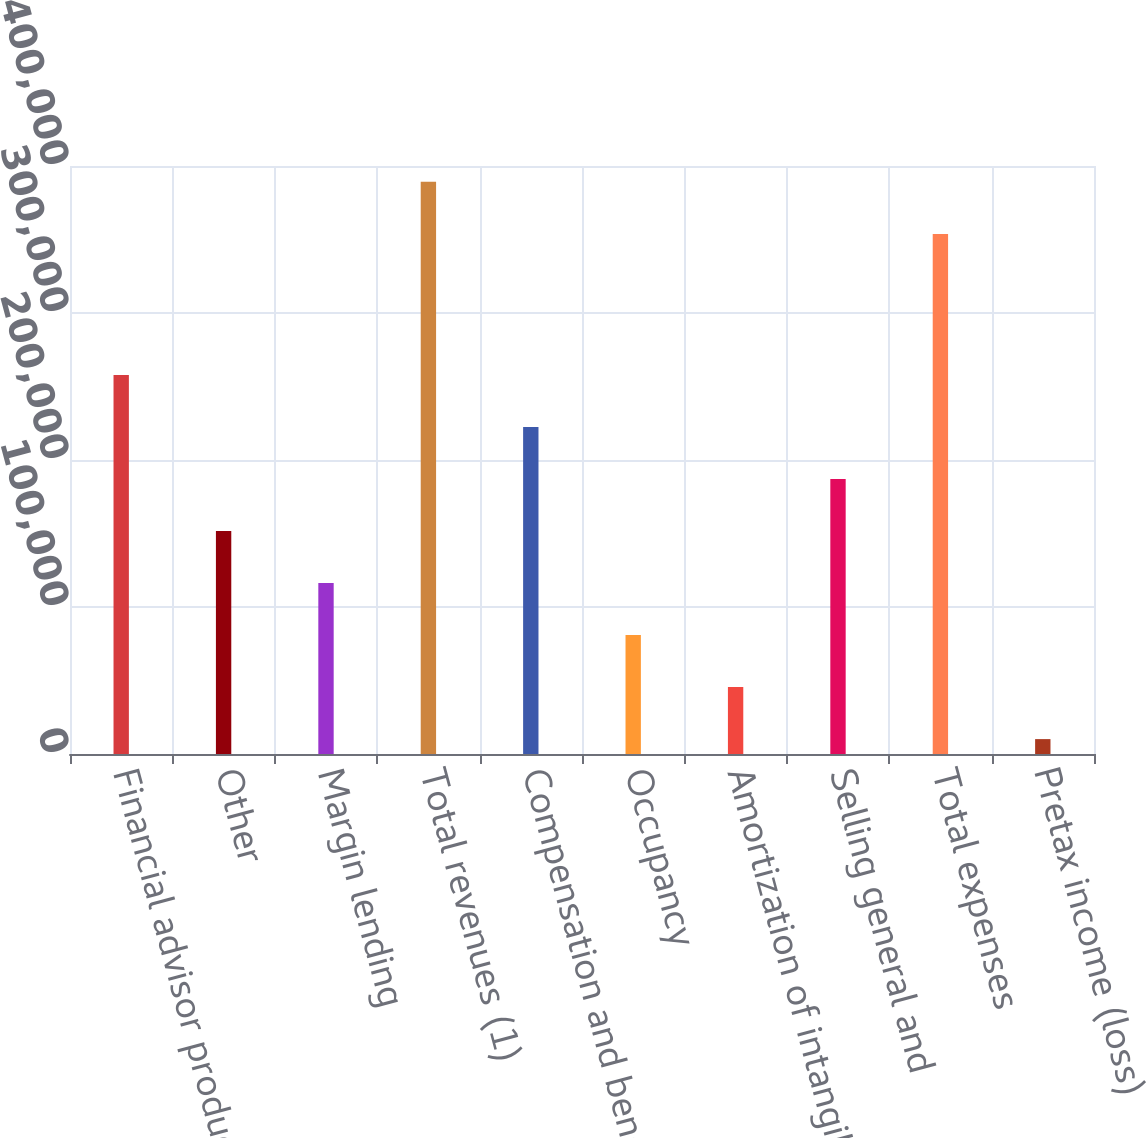Convert chart to OTSL. <chart><loc_0><loc_0><loc_500><loc_500><bar_chart><fcel>Financial advisor production<fcel>Other<fcel>Margin lending<fcel>Total revenues (1)<fcel>Compensation and benefits<fcel>Occupancy<fcel>Amortization of intangible<fcel>Selling general and<fcel>Total expenses<fcel>Pretax income (loss)<nl><fcel>257805<fcel>151658<fcel>116275<fcel>389206<fcel>222422<fcel>80892.8<fcel>45510.4<fcel>187040<fcel>353824<fcel>10128<nl></chart> 